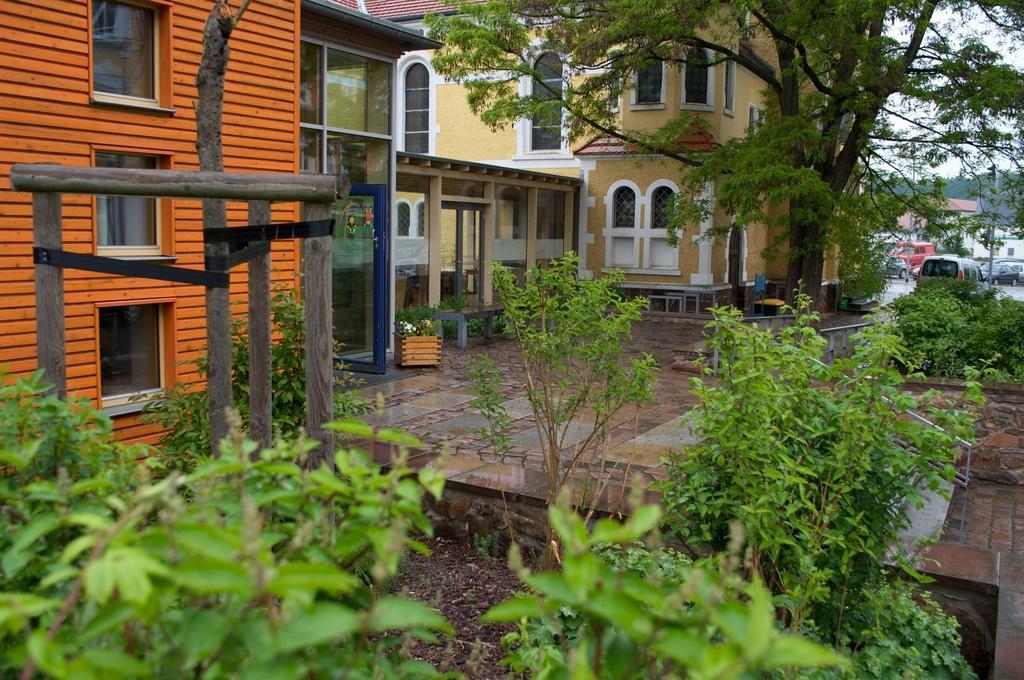In one or two sentences, can you explain what this image depicts? In this image, we can see trees, buildings, wooden poles, some plants and vehicles and there are benches. At the bottom, there is floor. 